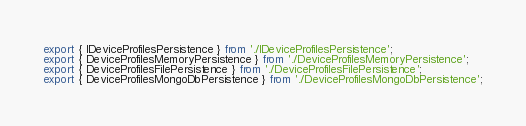Convert code to text. <code><loc_0><loc_0><loc_500><loc_500><_TypeScript_>export { IDeviceProfilesPersistence } from './IDeviceProfilesPersistence';
export { DeviceProfilesMemoryPersistence } from './DeviceProfilesMemoryPersistence';
export { DeviceProfilesFilePersistence } from './DeviceProfilesFilePersistence';
export { DeviceProfilesMongoDbPersistence } from './DeviceProfilesMongoDbPersistence';</code> 